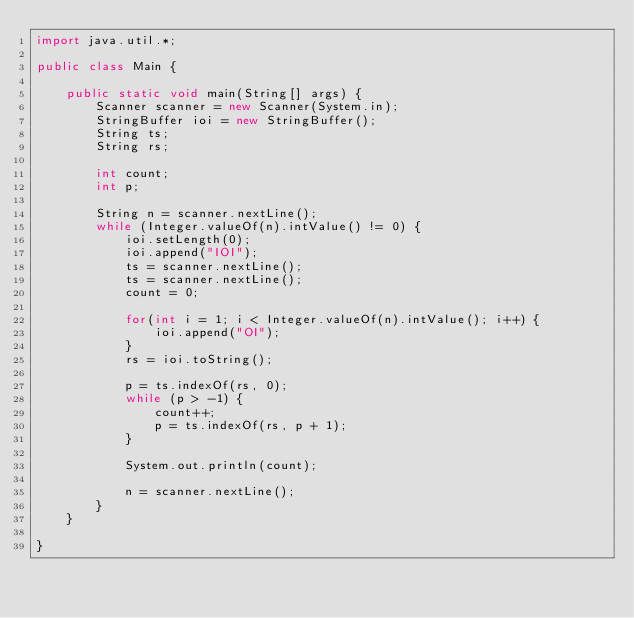Convert code to text. <code><loc_0><loc_0><loc_500><loc_500><_Java_>import java.util.*;

public class Main {

	public static void main(String[] args) {
		Scanner scanner = new Scanner(System.in);
		StringBuffer ioi = new StringBuffer();
		String ts;
		String rs;
	
		int count;
		int p;
		
		String n = scanner.nextLine();
		while (Integer.valueOf(n).intValue() != 0) {
			ioi.setLength(0);
			ioi.append("IOI");
			ts = scanner.nextLine();
			ts = scanner.nextLine();
			count = 0;
			
			for(int i = 1; i < Integer.valueOf(n).intValue(); i++) {
				ioi.append("OI");
			}
			rs = ioi.toString();
			
			p = ts.indexOf(rs, 0);
			while (p > -1) {
				count++;
				p = ts.indexOf(rs, p + 1);
			}
			
			System.out.println(count);
			
			n = scanner.nextLine();
		}
	}

}</code> 